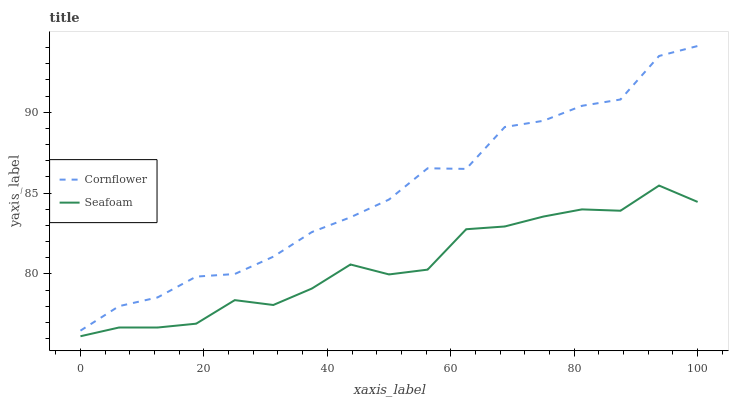Does Seafoam have the minimum area under the curve?
Answer yes or no. Yes. Does Cornflower have the maximum area under the curve?
Answer yes or no. Yes. Does Seafoam have the maximum area under the curve?
Answer yes or no. No. Is Cornflower the smoothest?
Answer yes or no. Yes. Is Seafoam the roughest?
Answer yes or no. Yes. Is Seafoam the smoothest?
Answer yes or no. No. Does Seafoam have the lowest value?
Answer yes or no. Yes. Does Cornflower have the highest value?
Answer yes or no. Yes. Does Seafoam have the highest value?
Answer yes or no. No. Is Seafoam less than Cornflower?
Answer yes or no. Yes. Is Cornflower greater than Seafoam?
Answer yes or no. Yes. Does Seafoam intersect Cornflower?
Answer yes or no. No. 